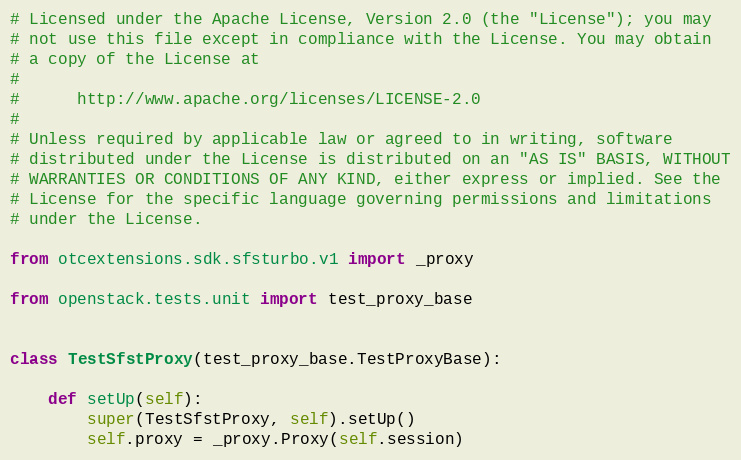Convert code to text. <code><loc_0><loc_0><loc_500><loc_500><_Python_># Licensed under the Apache License, Version 2.0 (the "License"); you may
# not use this file except in compliance with the License. You may obtain
# a copy of the License at
#
#      http://www.apache.org/licenses/LICENSE-2.0
#
# Unless required by applicable law or agreed to in writing, software
# distributed under the License is distributed on an "AS IS" BASIS, WITHOUT
# WARRANTIES OR CONDITIONS OF ANY KIND, either express or implied. See the
# License for the specific language governing permissions and limitations
# under the License.

from otcextensions.sdk.sfsturbo.v1 import _proxy

from openstack.tests.unit import test_proxy_base


class TestSfstProxy(test_proxy_base.TestProxyBase):

    def setUp(self):
        super(TestSfstProxy, self).setUp()
        self.proxy = _proxy.Proxy(self.session)
</code> 